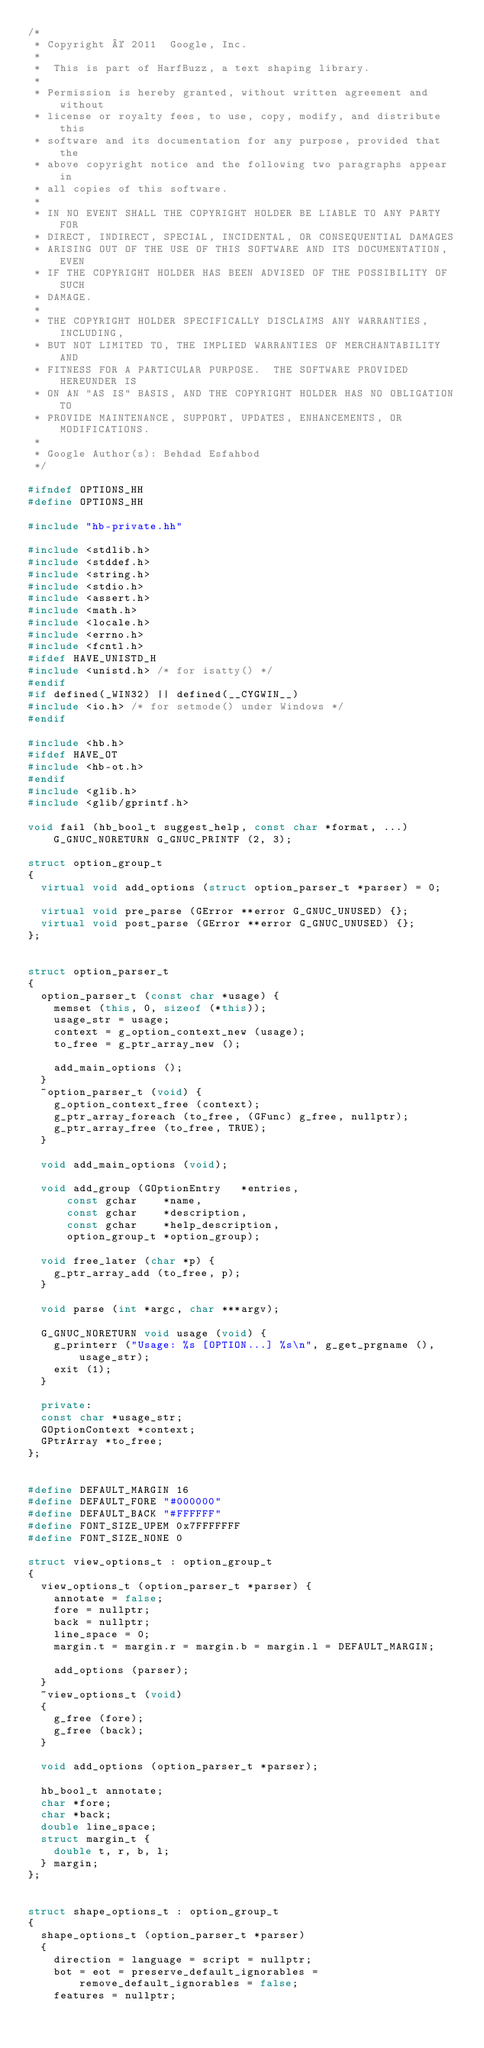<code> <loc_0><loc_0><loc_500><loc_500><_C++_>/*
 * Copyright © 2011  Google, Inc.
 *
 *  This is part of HarfBuzz, a text shaping library.
 *
 * Permission is hereby granted, without written agreement and without
 * license or royalty fees, to use, copy, modify, and distribute this
 * software and its documentation for any purpose, provided that the
 * above copyright notice and the following two paragraphs appear in
 * all copies of this software.
 *
 * IN NO EVENT SHALL THE COPYRIGHT HOLDER BE LIABLE TO ANY PARTY FOR
 * DIRECT, INDIRECT, SPECIAL, INCIDENTAL, OR CONSEQUENTIAL DAMAGES
 * ARISING OUT OF THE USE OF THIS SOFTWARE AND ITS DOCUMENTATION, EVEN
 * IF THE COPYRIGHT HOLDER HAS BEEN ADVISED OF THE POSSIBILITY OF SUCH
 * DAMAGE.
 *
 * THE COPYRIGHT HOLDER SPECIFICALLY DISCLAIMS ANY WARRANTIES, INCLUDING,
 * BUT NOT LIMITED TO, THE IMPLIED WARRANTIES OF MERCHANTABILITY AND
 * FITNESS FOR A PARTICULAR PURPOSE.  THE SOFTWARE PROVIDED HEREUNDER IS
 * ON AN "AS IS" BASIS, AND THE COPYRIGHT HOLDER HAS NO OBLIGATION TO
 * PROVIDE MAINTENANCE, SUPPORT, UPDATES, ENHANCEMENTS, OR MODIFICATIONS.
 *
 * Google Author(s): Behdad Esfahbod
 */

#ifndef OPTIONS_HH
#define OPTIONS_HH

#include "hb-private.hh"

#include <stdlib.h>
#include <stddef.h>
#include <string.h>
#include <stdio.h>
#include <assert.h>
#include <math.h>
#include <locale.h>
#include <errno.h>
#include <fcntl.h>
#ifdef HAVE_UNISTD_H
#include <unistd.h> /* for isatty() */
#endif
#if defined(_WIN32) || defined(__CYGWIN__)
#include <io.h> /* for setmode() under Windows */
#endif

#include <hb.h>
#ifdef HAVE_OT
#include <hb-ot.h>
#endif
#include <glib.h>
#include <glib/gprintf.h>

void fail (hb_bool_t suggest_help, const char *format, ...) G_GNUC_NORETURN G_GNUC_PRINTF (2, 3);

struct option_group_t
{
  virtual void add_options (struct option_parser_t *parser) = 0;

  virtual void pre_parse (GError **error G_GNUC_UNUSED) {};
  virtual void post_parse (GError **error G_GNUC_UNUSED) {};
};


struct option_parser_t
{
  option_parser_t (const char *usage) {
    memset (this, 0, sizeof (*this));
    usage_str = usage;
    context = g_option_context_new (usage);
    to_free = g_ptr_array_new ();

    add_main_options ();
  }
  ~option_parser_t (void) {
    g_option_context_free (context);
    g_ptr_array_foreach (to_free, (GFunc) g_free, nullptr);
    g_ptr_array_free (to_free, TRUE);
  }

  void add_main_options (void);

  void add_group (GOptionEntry   *entries,
		  const gchar    *name,
		  const gchar    *description,
		  const gchar    *help_description,
		  option_group_t *option_group);

  void free_later (char *p) {
    g_ptr_array_add (to_free, p);
  }

  void parse (int *argc, char ***argv);

  G_GNUC_NORETURN void usage (void) {
    g_printerr ("Usage: %s [OPTION...] %s\n", g_get_prgname (), usage_str);
    exit (1);
  }

  private:
  const char *usage_str;
  GOptionContext *context;
  GPtrArray *to_free;
};


#define DEFAULT_MARGIN 16
#define DEFAULT_FORE "#000000"
#define DEFAULT_BACK "#FFFFFF"
#define FONT_SIZE_UPEM 0x7FFFFFFF
#define FONT_SIZE_NONE 0

struct view_options_t : option_group_t
{
  view_options_t (option_parser_t *parser) {
    annotate = false;
    fore = nullptr;
    back = nullptr;
    line_space = 0;
    margin.t = margin.r = margin.b = margin.l = DEFAULT_MARGIN;

    add_options (parser);
  }
  ~view_options_t (void)
  {
    g_free (fore);
    g_free (back);
  }

  void add_options (option_parser_t *parser);

  hb_bool_t annotate;
  char *fore;
  char *back;
  double line_space;
  struct margin_t {
    double t, r, b, l;
  } margin;
};


struct shape_options_t : option_group_t
{
  shape_options_t (option_parser_t *parser)
  {
    direction = language = script = nullptr;
    bot = eot = preserve_default_ignorables = remove_default_ignorables = false;
    features = nullptr;</code> 